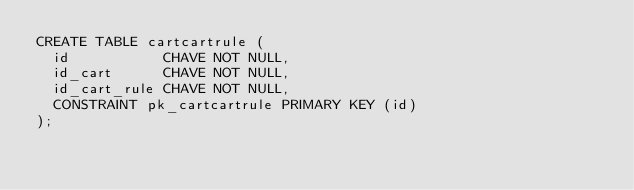Convert code to text. <code><loc_0><loc_0><loc_500><loc_500><_SQL_>CREATE TABLE cartcartrule (
  id           CHAVE NOT NULL,
  id_cart      CHAVE NOT NULL,
  id_cart_rule CHAVE NOT NULL,
  CONSTRAINT pk_cartcartrule PRIMARY KEY (id)
);</code> 